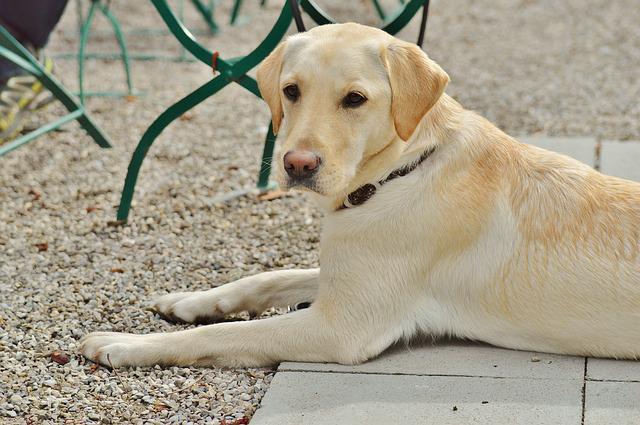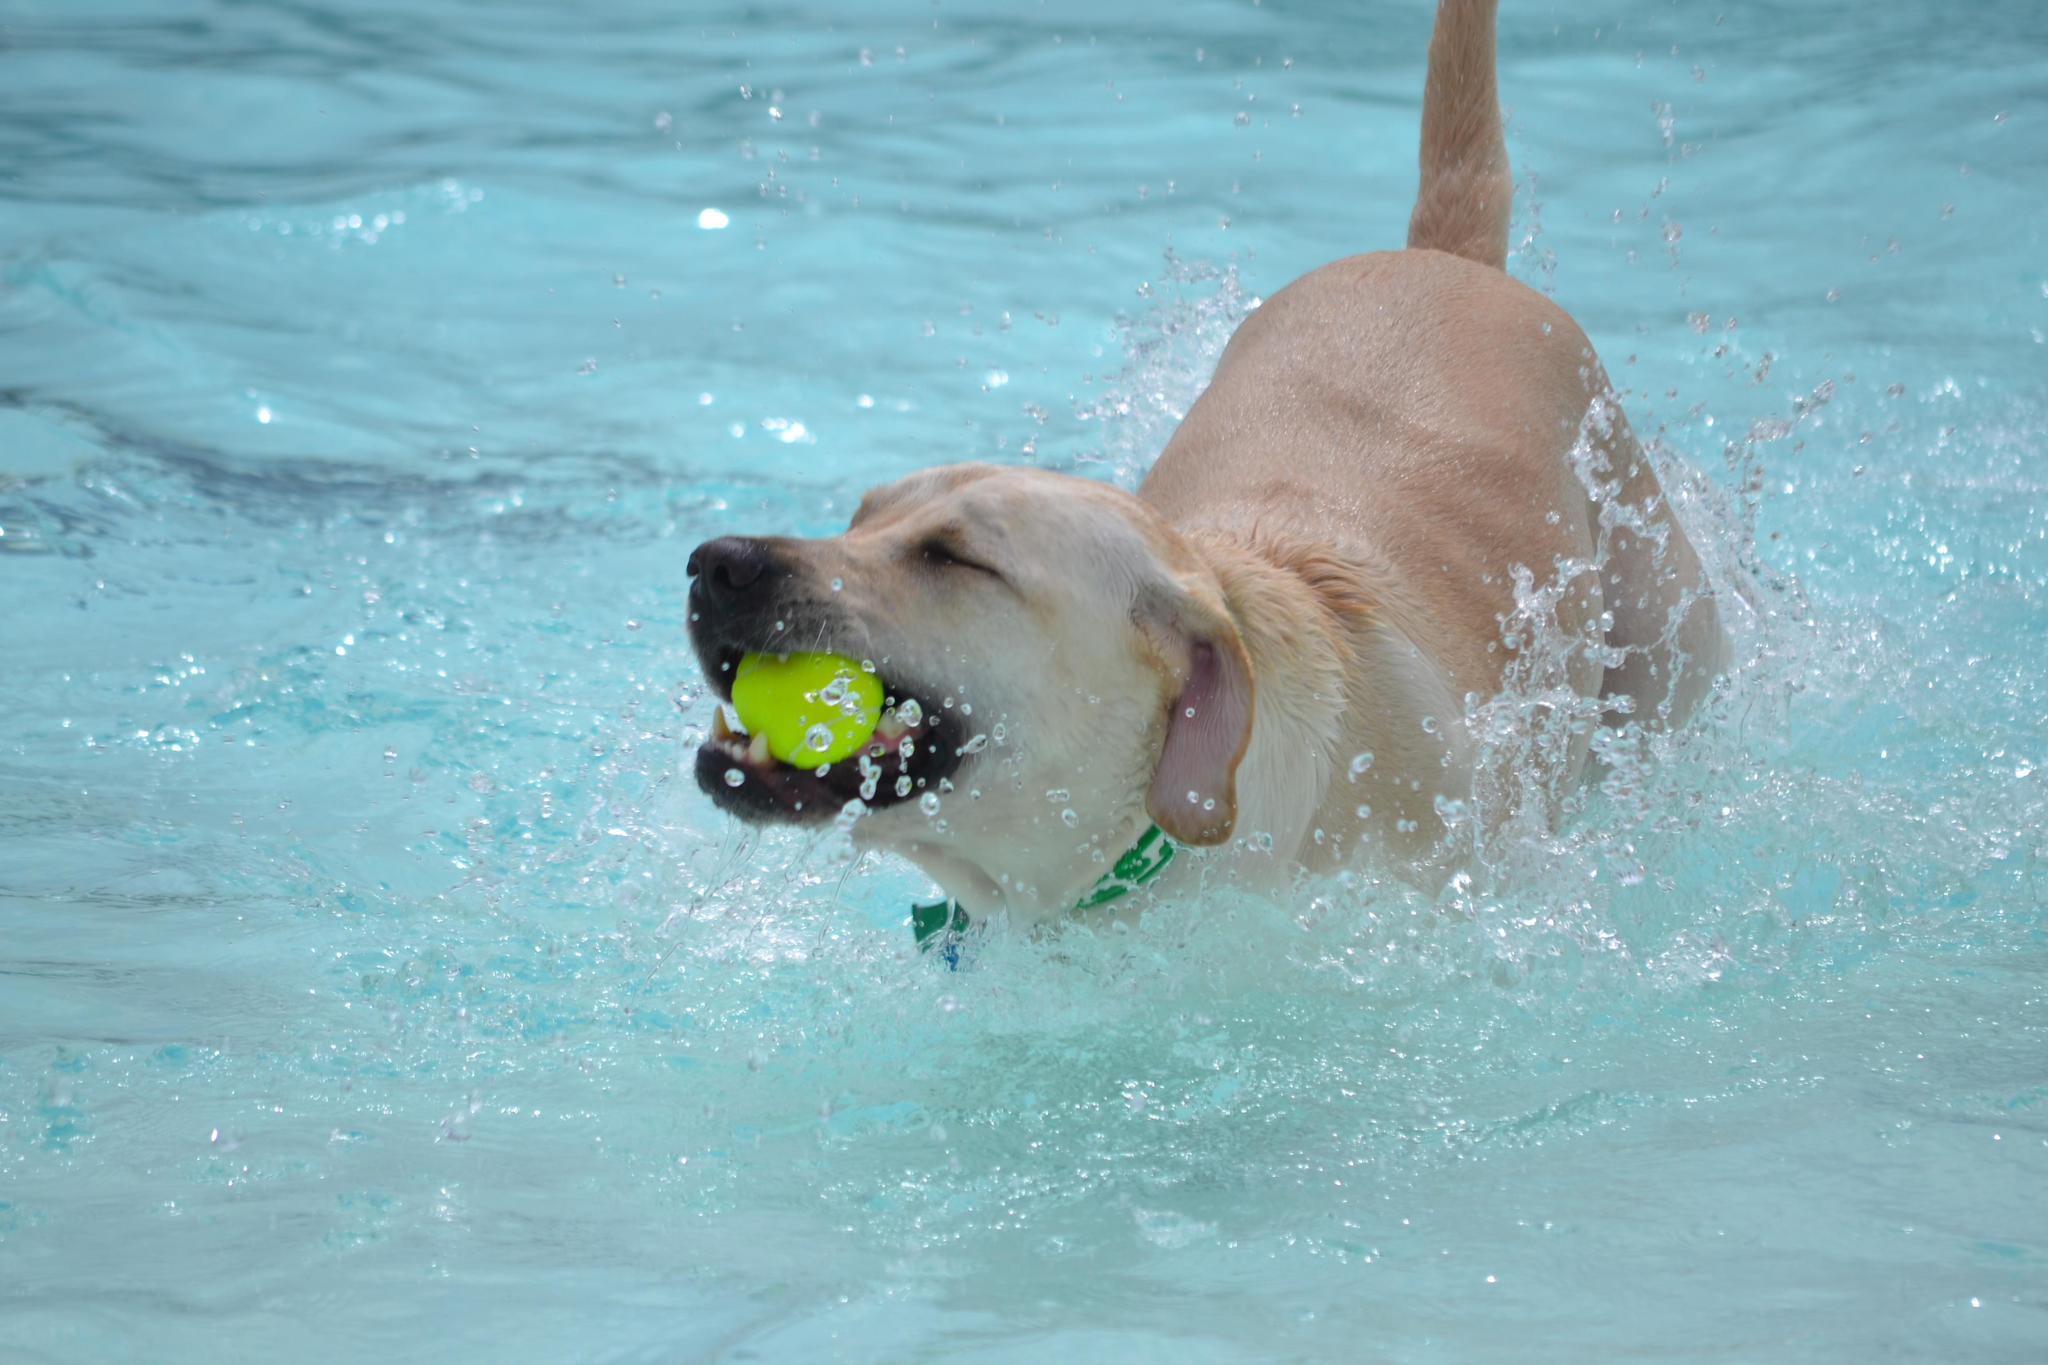The first image is the image on the left, the second image is the image on the right. Considering the images on both sides, is "One dog has something in its mouth." valid? Answer yes or no. Yes. The first image is the image on the left, the second image is the image on the right. Assess this claim about the two images: "a dog is swimming while carrying something in it's mouth". Correct or not? Answer yes or no. Yes. 